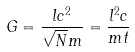Convert formula to latex. <formula><loc_0><loc_0><loc_500><loc_500>G = \frac { l c ^ { 2 } } { \sqrt { N } m } = \frac { l ^ { 2 } c } { m t }</formula> 